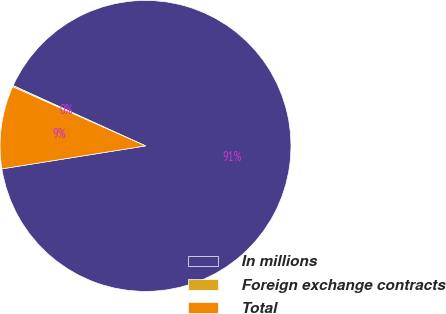<chart> <loc_0><loc_0><loc_500><loc_500><pie_chart><fcel>In millions<fcel>Foreign exchange contracts<fcel>Total<nl><fcel>90.68%<fcel>0.14%<fcel>9.19%<nl></chart> 